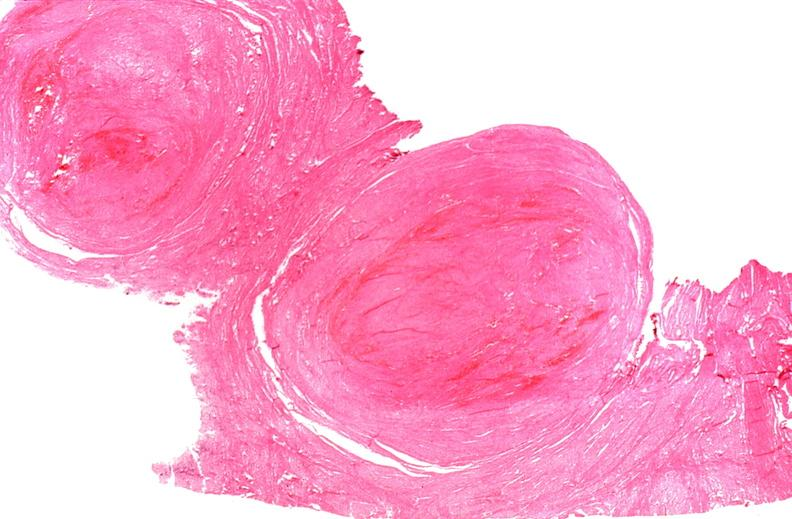s there present?
Answer the question using a single word or phrase. No 